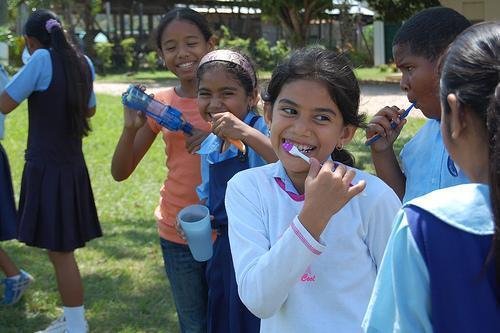How many toothbrushes are there?
Give a very brief answer. 2. 